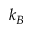<formula> <loc_0><loc_0><loc_500><loc_500>k _ { B }</formula> 